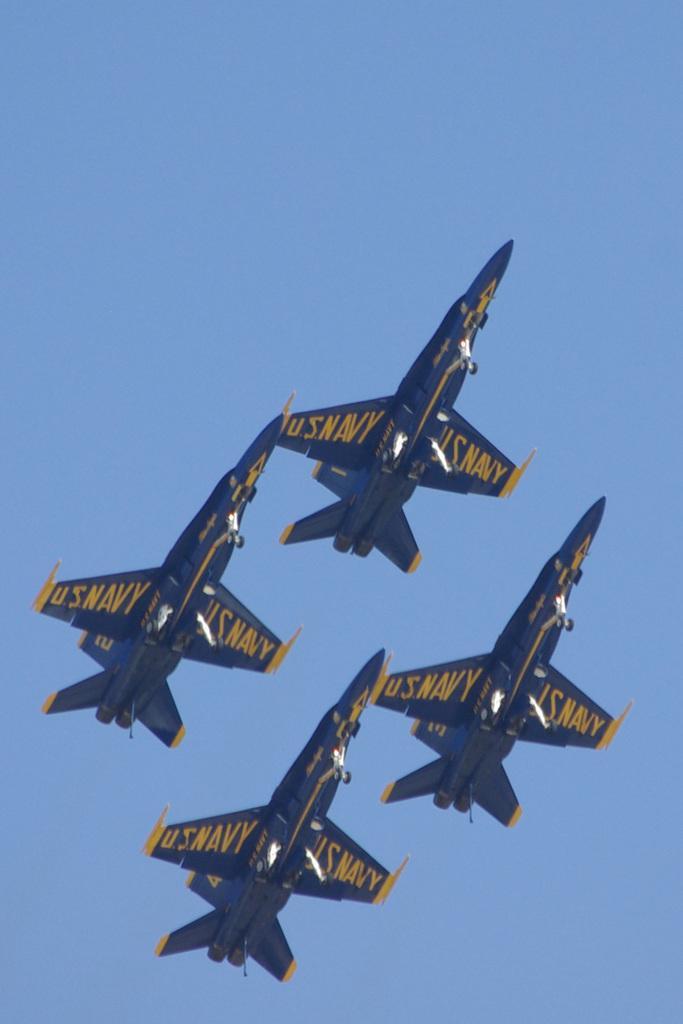Describe this image in one or two sentences. In this image I see 4 aircrafts which are of blue and yellow in color and I see words written on it and in the background I see the blue sky. 